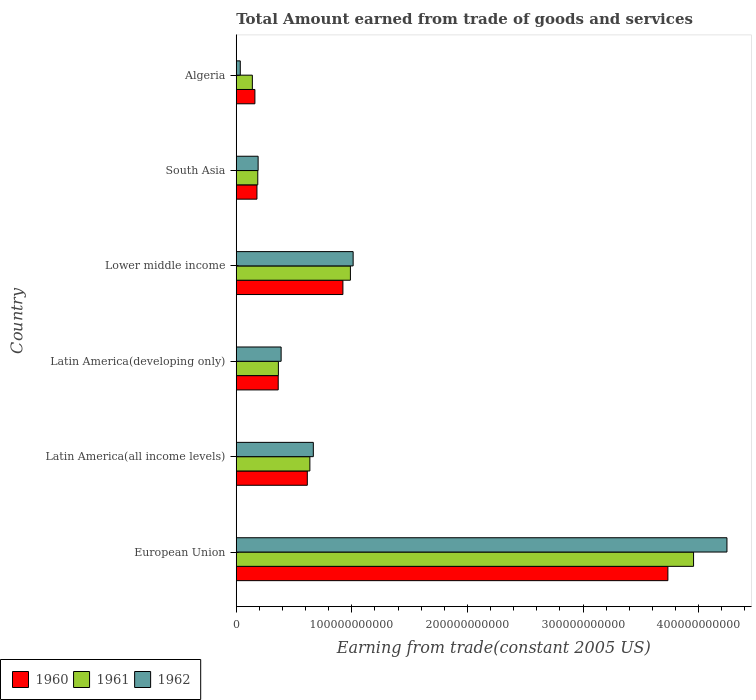How many groups of bars are there?
Keep it short and to the point. 6. Are the number of bars on each tick of the Y-axis equal?
Make the answer very short. Yes. How many bars are there on the 4th tick from the top?
Your answer should be very brief. 3. What is the label of the 5th group of bars from the top?
Provide a succinct answer. Latin America(all income levels). What is the total amount earned by trading goods and services in 1961 in Lower middle income?
Provide a short and direct response. 9.88e+1. Across all countries, what is the maximum total amount earned by trading goods and services in 1961?
Provide a short and direct response. 3.96e+11. Across all countries, what is the minimum total amount earned by trading goods and services in 1961?
Ensure brevity in your answer.  1.39e+1. In which country was the total amount earned by trading goods and services in 1961 maximum?
Give a very brief answer. European Union. In which country was the total amount earned by trading goods and services in 1962 minimum?
Your answer should be very brief. Algeria. What is the total total amount earned by trading goods and services in 1961 in the graph?
Make the answer very short. 6.27e+11. What is the difference between the total amount earned by trading goods and services in 1961 in Algeria and that in South Asia?
Provide a succinct answer. -4.69e+09. What is the difference between the total amount earned by trading goods and services in 1960 in South Asia and the total amount earned by trading goods and services in 1962 in Latin America(developing only)?
Offer a terse response. -2.09e+1. What is the average total amount earned by trading goods and services in 1961 per country?
Your answer should be compact. 1.05e+11. What is the difference between the total amount earned by trading goods and services in 1960 and total amount earned by trading goods and services in 1961 in European Union?
Offer a very short reply. -2.22e+1. What is the ratio of the total amount earned by trading goods and services in 1960 in Algeria to that in Lower middle income?
Provide a succinct answer. 0.17. Is the total amount earned by trading goods and services in 1961 in Lower middle income less than that in South Asia?
Your response must be concise. No. Is the difference between the total amount earned by trading goods and services in 1960 in European Union and Latin America(all income levels) greater than the difference between the total amount earned by trading goods and services in 1961 in European Union and Latin America(all income levels)?
Ensure brevity in your answer.  No. What is the difference between the highest and the second highest total amount earned by trading goods and services in 1962?
Provide a short and direct response. 3.23e+11. What is the difference between the highest and the lowest total amount earned by trading goods and services in 1961?
Your answer should be very brief. 3.82e+11. In how many countries, is the total amount earned by trading goods and services in 1962 greater than the average total amount earned by trading goods and services in 1962 taken over all countries?
Ensure brevity in your answer.  1. Is the sum of the total amount earned by trading goods and services in 1962 in Lower middle income and South Asia greater than the maximum total amount earned by trading goods and services in 1961 across all countries?
Keep it short and to the point. No. What does the 2nd bar from the top in South Asia represents?
Your response must be concise. 1961. What does the 2nd bar from the bottom in South Asia represents?
Ensure brevity in your answer.  1961. How many bars are there?
Offer a terse response. 18. Are all the bars in the graph horizontal?
Keep it short and to the point. Yes. What is the difference between two consecutive major ticks on the X-axis?
Make the answer very short. 1.00e+11. Does the graph contain grids?
Provide a succinct answer. No. Where does the legend appear in the graph?
Offer a terse response. Bottom left. How many legend labels are there?
Keep it short and to the point. 3. How are the legend labels stacked?
Provide a succinct answer. Horizontal. What is the title of the graph?
Provide a short and direct response. Total Amount earned from trade of goods and services. What is the label or title of the X-axis?
Ensure brevity in your answer.  Earning from trade(constant 2005 US). What is the Earning from trade(constant 2005 US) in 1960 in European Union?
Provide a succinct answer. 3.73e+11. What is the Earning from trade(constant 2005 US) of 1961 in European Union?
Offer a very short reply. 3.96e+11. What is the Earning from trade(constant 2005 US) of 1962 in European Union?
Give a very brief answer. 4.24e+11. What is the Earning from trade(constant 2005 US) in 1960 in Latin America(all income levels)?
Offer a terse response. 6.15e+1. What is the Earning from trade(constant 2005 US) of 1961 in Latin America(all income levels)?
Make the answer very short. 6.37e+1. What is the Earning from trade(constant 2005 US) in 1962 in Latin America(all income levels)?
Give a very brief answer. 6.67e+1. What is the Earning from trade(constant 2005 US) of 1960 in Latin America(developing only)?
Your answer should be compact. 3.63e+1. What is the Earning from trade(constant 2005 US) of 1961 in Latin America(developing only)?
Make the answer very short. 3.64e+1. What is the Earning from trade(constant 2005 US) of 1962 in Latin America(developing only)?
Give a very brief answer. 3.88e+1. What is the Earning from trade(constant 2005 US) of 1960 in Lower middle income?
Your answer should be very brief. 9.23e+1. What is the Earning from trade(constant 2005 US) in 1961 in Lower middle income?
Offer a very short reply. 9.88e+1. What is the Earning from trade(constant 2005 US) of 1962 in Lower middle income?
Make the answer very short. 1.01e+11. What is the Earning from trade(constant 2005 US) in 1960 in South Asia?
Your answer should be compact. 1.79e+1. What is the Earning from trade(constant 2005 US) of 1961 in South Asia?
Offer a terse response. 1.86e+1. What is the Earning from trade(constant 2005 US) in 1962 in South Asia?
Keep it short and to the point. 1.89e+1. What is the Earning from trade(constant 2005 US) of 1960 in Algeria?
Your response must be concise. 1.61e+1. What is the Earning from trade(constant 2005 US) in 1961 in Algeria?
Ensure brevity in your answer.  1.39e+1. What is the Earning from trade(constant 2005 US) of 1962 in Algeria?
Offer a terse response. 3.48e+09. Across all countries, what is the maximum Earning from trade(constant 2005 US) in 1960?
Your response must be concise. 3.73e+11. Across all countries, what is the maximum Earning from trade(constant 2005 US) in 1961?
Your answer should be compact. 3.96e+11. Across all countries, what is the maximum Earning from trade(constant 2005 US) in 1962?
Give a very brief answer. 4.24e+11. Across all countries, what is the minimum Earning from trade(constant 2005 US) in 1960?
Offer a terse response. 1.61e+1. Across all countries, what is the minimum Earning from trade(constant 2005 US) in 1961?
Your answer should be very brief. 1.39e+1. Across all countries, what is the minimum Earning from trade(constant 2005 US) in 1962?
Provide a succinct answer. 3.48e+09. What is the total Earning from trade(constant 2005 US) in 1960 in the graph?
Your answer should be very brief. 5.97e+11. What is the total Earning from trade(constant 2005 US) in 1961 in the graph?
Provide a succinct answer. 6.27e+11. What is the total Earning from trade(constant 2005 US) in 1962 in the graph?
Offer a very short reply. 6.54e+11. What is the difference between the Earning from trade(constant 2005 US) of 1960 in European Union and that in Latin America(all income levels)?
Ensure brevity in your answer.  3.12e+11. What is the difference between the Earning from trade(constant 2005 US) of 1961 in European Union and that in Latin America(all income levels)?
Provide a succinct answer. 3.32e+11. What is the difference between the Earning from trade(constant 2005 US) of 1962 in European Union and that in Latin America(all income levels)?
Keep it short and to the point. 3.58e+11. What is the difference between the Earning from trade(constant 2005 US) of 1960 in European Union and that in Latin America(developing only)?
Your answer should be compact. 3.37e+11. What is the difference between the Earning from trade(constant 2005 US) in 1961 in European Union and that in Latin America(developing only)?
Give a very brief answer. 3.59e+11. What is the difference between the Earning from trade(constant 2005 US) in 1962 in European Union and that in Latin America(developing only)?
Provide a succinct answer. 3.86e+11. What is the difference between the Earning from trade(constant 2005 US) of 1960 in European Union and that in Lower middle income?
Your answer should be very brief. 2.81e+11. What is the difference between the Earning from trade(constant 2005 US) in 1961 in European Union and that in Lower middle income?
Your response must be concise. 2.97e+11. What is the difference between the Earning from trade(constant 2005 US) of 1962 in European Union and that in Lower middle income?
Provide a succinct answer. 3.23e+11. What is the difference between the Earning from trade(constant 2005 US) in 1960 in European Union and that in South Asia?
Provide a succinct answer. 3.55e+11. What is the difference between the Earning from trade(constant 2005 US) in 1961 in European Union and that in South Asia?
Your answer should be very brief. 3.77e+11. What is the difference between the Earning from trade(constant 2005 US) of 1962 in European Union and that in South Asia?
Ensure brevity in your answer.  4.06e+11. What is the difference between the Earning from trade(constant 2005 US) of 1960 in European Union and that in Algeria?
Give a very brief answer. 3.57e+11. What is the difference between the Earning from trade(constant 2005 US) in 1961 in European Union and that in Algeria?
Keep it short and to the point. 3.82e+11. What is the difference between the Earning from trade(constant 2005 US) in 1962 in European Union and that in Algeria?
Offer a very short reply. 4.21e+11. What is the difference between the Earning from trade(constant 2005 US) in 1960 in Latin America(all income levels) and that in Latin America(developing only)?
Make the answer very short. 2.52e+1. What is the difference between the Earning from trade(constant 2005 US) of 1961 in Latin America(all income levels) and that in Latin America(developing only)?
Give a very brief answer. 2.72e+1. What is the difference between the Earning from trade(constant 2005 US) of 1962 in Latin America(all income levels) and that in Latin America(developing only)?
Your answer should be compact. 2.79e+1. What is the difference between the Earning from trade(constant 2005 US) of 1960 in Latin America(all income levels) and that in Lower middle income?
Make the answer very short. -3.08e+1. What is the difference between the Earning from trade(constant 2005 US) of 1961 in Latin America(all income levels) and that in Lower middle income?
Your response must be concise. -3.51e+1. What is the difference between the Earning from trade(constant 2005 US) of 1962 in Latin America(all income levels) and that in Lower middle income?
Your answer should be compact. -3.45e+1. What is the difference between the Earning from trade(constant 2005 US) of 1960 in Latin America(all income levels) and that in South Asia?
Make the answer very short. 4.36e+1. What is the difference between the Earning from trade(constant 2005 US) of 1961 in Latin America(all income levels) and that in South Asia?
Provide a short and direct response. 4.51e+1. What is the difference between the Earning from trade(constant 2005 US) of 1962 in Latin America(all income levels) and that in South Asia?
Keep it short and to the point. 4.77e+1. What is the difference between the Earning from trade(constant 2005 US) of 1960 in Latin America(all income levels) and that in Algeria?
Provide a short and direct response. 4.53e+1. What is the difference between the Earning from trade(constant 2005 US) in 1961 in Latin America(all income levels) and that in Algeria?
Your response must be concise. 4.98e+1. What is the difference between the Earning from trade(constant 2005 US) of 1962 in Latin America(all income levels) and that in Algeria?
Your answer should be compact. 6.32e+1. What is the difference between the Earning from trade(constant 2005 US) of 1960 in Latin America(developing only) and that in Lower middle income?
Provide a short and direct response. -5.60e+1. What is the difference between the Earning from trade(constant 2005 US) in 1961 in Latin America(developing only) and that in Lower middle income?
Provide a short and direct response. -6.23e+1. What is the difference between the Earning from trade(constant 2005 US) in 1962 in Latin America(developing only) and that in Lower middle income?
Your answer should be compact. -6.23e+1. What is the difference between the Earning from trade(constant 2005 US) in 1960 in Latin America(developing only) and that in South Asia?
Provide a short and direct response. 1.84e+1. What is the difference between the Earning from trade(constant 2005 US) of 1961 in Latin America(developing only) and that in South Asia?
Your answer should be very brief. 1.78e+1. What is the difference between the Earning from trade(constant 2005 US) of 1962 in Latin America(developing only) and that in South Asia?
Your answer should be compact. 1.99e+1. What is the difference between the Earning from trade(constant 2005 US) of 1960 in Latin America(developing only) and that in Algeria?
Offer a terse response. 2.02e+1. What is the difference between the Earning from trade(constant 2005 US) in 1961 in Latin America(developing only) and that in Algeria?
Give a very brief answer. 2.25e+1. What is the difference between the Earning from trade(constant 2005 US) of 1962 in Latin America(developing only) and that in Algeria?
Give a very brief answer. 3.53e+1. What is the difference between the Earning from trade(constant 2005 US) in 1960 in Lower middle income and that in South Asia?
Your response must be concise. 7.44e+1. What is the difference between the Earning from trade(constant 2005 US) in 1961 in Lower middle income and that in South Asia?
Keep it short and to the point. 8.01e+1. What is the difference between the Earning from trade(constant 2005 US) of 1962 in Lower middle income and that in South Asia?
Your answer should be compact. 8.22e+1. What is the difference between the Earning from trade(constant 2005 US) of 1960 in Lower middle income and that in Algeria?
Provide a succinct answer. 7.61e+1. What is the difference between the Earning from trade(constant 2005 US) in 1961 in Lower middle income and that in Algeria?
Ensure brevity in your answer.  8.48e+1. What is the difference between the Earning from trade(constant 2005 US) of 1962 in Lower middle income and that in Algeria?
Your answer should be compact. 9.76e+1. What is the difference between the Earning from trade(constant 2005 US) of 1960 in South Asia and that in Algeria?
Your response must be concise. 1.77e+09. What is the difference between the Earning from trade(constant 2005 US) in 1961 in South Asia and that in Algeria?
Offer a terse response. 4.69e+09. What is the difference between the Earning from trade(constant 2005 US) in 1962 in South Asia and that in Algeria?
Offer a very short reply. 1.54e+1. What is the difference between the Earning from trade(constant 2005 US) of 1960 in European Union and the Earning from trade(constant 2005 US) of 1961 in Latin America(all income levels)?
Offer a very short reply. 3.10e+11. What is the difference between the Earning from trade(constant 2005 US) in 1960 in European Union and the Earning from trade(constant 2005 US) in 1962 in Latin America(all income levels)?
Make the answer very short. 3.07e+11. What is the difference between the Earning from trade(constant 2005 US) in 1961 in European Union and the Earning from trade(constant 2005 US) in 1962 in Latin America(all income levels)?
Offer a terse response. 3.29e+11. What is the difference between the Earning from trade(constant 2005 US) in 1960 in European Union and the Earning from trade(constant 2005 US) in 1961 in Latin America(developing only)?
Make the answer very short. 3.37e+11. What is the difference between the Earning from trade(constant 2005 US) in 1960 in European Union and the Earning from trade(constant 2005 US) in 1962 in Latin America(developing only)?
Keep it short and to the point. 3.35e+11. What is the difference between the Earning from trade(constant 2005 US) of 1961 in European Union and the Earning from trade(constant 2005 US) of 1962 in Latin America(developing only)?
Your answer should be compact. 3.57e+11. What is the difference between the Earning from trade(constant 2005 US) of 1960 in European Union and the Earning from trade(constant 2005 US) of 1961 in Lower middle income?
Your answer should be compact. 2.75e+11. What is the difference between the Earning from trade(constant 2005 US) of 1960 in European Union and the Earning from trade(constant 2005 US) of 1962 in Lower middle income?
Give a very brief answer. 2.72e+11. What is the difference between the Earning from trade(constant 2005 US) of 1961 in European Union and the Earning from trade(constant 2005 US) of 1962 in Lower middle income?
Provide a succinct answer. 2.94e+11. What is the difference between the Earning from trade(constant 2005 US) of 1960 in European Union and the Earning from trade(constant 2005 US) of 1961 in South Asia?
Keep it short and to the point. 3.55e+11. What is the difference between the Earning from trade(constant 2005 US) in 1960 in European Union and the Earning from trade(constant 2005 US) in 1962 in South Asia?
Provide a succinct answer. 3.54e+11. What is the difference between the Earning from trade(constant 2005 US) of 1961 in European Union and the Earning from trade(constant 2005 US) of 1962 in South Asia?
Offer a terse response. 3.77e+11. What is the difference between the Earning from trade(constant 2005 US) in 1960 in European Union and the Earning from trade(constant 2005 US) in 1961 in Algeria?
Give a very brief answer. 3.59e+11. What is the difference between the Earning from trade(constant 2005 US) of 1960 in European Union and the Earning from trade(constant 2005 US) of 1962 in Algeria?
Your response must be concise. 3.70e+11. What is the difference between the Earning from trade(constant 2005 US) of 1961 in European Union and the Earning from trade(constant 2005 US) of 1962 in Algeria?
Your response must be concise. 3.92e+11. What is the difference between the Earning from trade(constant 2005 US) in 1960 in Latin America(all income levels) and the Earning from trade(constant 2005 US) in 1961 in Latin America(developing only)?
Your answer should be very brief. 2.50e+1. What is the difference between the Earning from trade(constant 2005 US) of 1960 in Latin America(all income levels) and the Earning from trade(constant 2005 US) of 1962 in Latin America(developing only)?
Your answer should be very brief. 2.27e+1. What is the difference between the Earning from trade(constant 2005 US) in 1961 in Latin America(all income levels) and the Earning from trade(constant 2005 US) in 1962 in Latin America(developing only)?
Provide a succinct answer. 2.49e+1. What is the difference between the Earning from trade(constant 2005 US) in 1960 in Latin America(all income levels) and the Earning from trade(constant 2005 US) in 1961 in Lower middle income?
Make the answer very short. -3.73e+1. What is the difference between the Earning from trade(constant 2005 US) in 1960 in Latin America(all income levels) and the Earning from trade(constant 2005 US) in 1962 in Lower middle income?
Provide a short and direct response. -3.96e+1. What is the difference between the Earning from trade(constant 2005 US) of 1961 in Latin America(all income levels) and the Earning from trade(constant 2005 US) of 1962 in Lower middle income?
Offer a very short reply. -3.74e+1. What is the difference between the Earning from trade(constant 2005 US) in 1960 in Latin America(all income levels) and the Earning from trade(constant 2005 US) in 1961 in South Asia?
Your answer should be very brief. 4.29e+1. What is the difference between the Earning from trade(constant 2005 US) of 1960 in Latin America(all income levels) and the Earning from trade(constant 2005 US) of 1962 in South Asia?
Ensure brevity in your answer.  4.26e+1. What is the difference between the Earning from trade(constant 2005 US) of 1961 in Latin America(all income levels) and the Earning from trade(constant 2005 US) of 1962 in South Asia?
Ensure brevity in your answer.  4.48e+1. What is the difference between the Earning from trade(constant 2005 US) of 1960 in Latin America(all income levels) and the Earning from trade(constant 2005 US) of 1961 in Algeria?
Your answer should be very brief. 4.75e+1. What is the difference between the Earning from trade(constant 2005 US) of 1960 in Latin America(all income levels) and the Earning from trade(constant 2005 US) of 1962 in Algeria?
Provide a short and direct response. 5.80e+1. What is the difference between the Earning from trade(constant 2005 US) of 1961 in Latin America(all income levels) and the Earning from trade(constant 2005 US) of 1962 in Algeria?
Make the answer very short. 6.02e+1. What is the difference between the Earning from trade(constant 2005 US) in 1960 in Latin America(developing only) and the Earning from trade(constant 2005 US) in 1961 in Lower middle income?
Offer a terse response. -6.25e+1. What is the difference between the Earning from trade(constant 2005 US) of 1960 in Latin America(developing only) and the Earning from trade(constant 2005 US) of 1962 in Lower middle income?
Ensure brevity in your answer.  -6.48e+1. What is the difference between the Earning from trade(constant 2005 US) of 1961 in Latin America(developing only) and the Earning from trade(constant 2005 US) of 1962 in Lower middle income?
Keep it short and to the point. -6.47e+1. What is the difference between the Earning from trade(constant 2005 US) in 1960 in Latin America(developing only) and the Earning from trade(constant 2005 US) in 1961 in South Asia?
Your answer should be compact. 1.77e+1. What is the difference between the Earning from trade(constant 2005 US) in 1960 in Latin America(developing only) and the Earning from trade(constant 2005 US) in 1962 in South Asia?
Your answer should be compact. 1.74e+1. What is the difference between the Earning from trade(constant 2005 US) in 1961 in Latin America(developing only) and the Earning from trade(constant 2005 US) in 1962 in South Asia?
Offer a terse response. 1.75e+1. What is the difference between the Earning from trade(constant 2005 US) in 1960 in Latin America(developing only) and the Earning from trade(constant 2005 US) in 1961 in Algeria?
Offer a very short reply. 2.24e+1. What is the difference between the Earning from trade(constant 2005 US) in 1960 in Latin America(developing only) and the Earning from trade(constant 2005 US) in 1962 in Algeria?
Make the answer very short. 3.28e+1. What is the difference between the Earning from trade(constant 2005 US) in 1961 in Latin America(developing only) and the Earning from trade(constant 2005 US) in 1962 in Algeria?
Offer a very short reply. 3.30e+1. What is the difference between the Earning from trade(constant 2005 US) in 1960 in Lower middle income and the Earning from trade(constant 2005 US) in 1961 in South Asia?
Offer a very short reply. 7.36e+1. What is the difference between the Earning from trade(constant 2005 US) of 1960 in Lower middle income and the Earning from trade(constant 2005 US) of 1962 in South Asia?
Provide a short and direct response. 7.33e+1. What is the difference between the Earning from trade(constant 2005 US) of 1961 in Lower middle income and the Earning from trade(constant 2005 US) of 1962 in South Asia?
Keep it short and to the point. 7.98e+1. What is the difference between the Earning from trade(constant 2005 US) in 1960 in Lower middle income and the Earning from trade(constant 2005 US) in 1961 in Algeria?
Offer a very short reply. 7.83e+1. What is the difference between the Earning from trade(constant 2005 US) in 1960 in Lower middle income and the Earning from trade(constant 2005 US) in 1962 in Algeria?
Offer a very short reply. 8.88e+1. What is the difference between the Earning from trade(constant 2005 US) of 1961 in Lower middle income and the Earning from trade(constant 2005 US) of 1962 in Algeria?
Keep it short and to the point. 9.53e+1. What is the difference between the Earning from trade(constant 2005 US) of 1960 in South Asia and the Earning from trade(constant 2005 US) of 1961 in Algeria?
Your answer should be very brief. 3.97e+09. What is the difference between the Earning from trade(constant 2005 US) of 1960 in South Asia and the Earning from trade(constant 2005 US) of 1962 in Algeria?
Keep it short and to the point. 1.44e+1. What is the difference between the Earning from trade(constant 2005 US) of 1961 in South Asia and the Earning from trade(constant 2005 US) of 1962 in Algeria?
Ensure brevity in your answer.  1.51e+1. What is the average Earning from trade(constant 2005 US) in 1960 per country?
Offer a terse response. 9.96e+1. What is the average Earning from trade(constant 2005 US) of 1961 per country?
Your answer should be compact. 1.05e+11. What is the average Earning from trade(constant 2005 US) of 1962 per country?
Your answer should be very brief. 1.09e+11. What is the difference between the Earning from trade(constant 2005 US) in 1960 and Earning from trade(constant 2005 US) in 1961 in European Union?
Offer a very short reply. -2.22e+1. What is the difference between the Earning from trade(constant 2005 US) in 1960 and Earning from trade(constant 2005 US) in 1962 in European Union?
Provide a short and direct response. -5.11e+1. What is the difference between the Earning from trade(constant 2005 US) in 1961 and Earning from trade(constant 2005 US) in 1962 in European Union?
Your response must be concise. -2.89e+1. What is the difference between the Earning from trade(constant 2005 US) of 1960 and Earning from trade(constant 2005 US) of 1961 in Latin America(all income levels)?
Offer a terse response. -2.22e+09. What is the difference between the Earning from trade(constant 2005 US) of 1960 and Earning from trade(constant 2005 US) of 1962 in Latin America(all income levels)?
Offer a very short reply. -5.20e+09. What is the difference between the Earning from trade(constant 2005 US) in 1961 and Earning from trade(constant 2005 US) in 1962 in Latin America(all income levels)?
Provide a short and direct response. -2.97e+09. What is the difference between the Earning from trade(constant 2005 US) in 1960 and Earning from trade(constant 2005 US) in 1961 in Latin America(developing only)?
Your answer should be compact. -1.49e+08. What is the difference between the Earning from trade(constant 2005 US) in 1960 and Earning from trade(constant 2005 US) in 1962 in Latin America(developing only)?
Your response must be concise. -2.52e+09. What is the difference between the Earning from trade(constant 2005 US) in 1961 and Earning from trade(constant 2005 US) in 1962 in Latin America(developing only)?
Make the answer very short. -2.37e+09. What is the difference between the Earning from trade(constant 2005 US) of 1960 and Earning from trade(constant 2005 US) of 1961 in Lower middle income?
Provide a short and direct response. -6.49e+09. What is the difference between the Earning from trade(constant 2005 US) in 1960 and Earning from trade(constant 2005 US) in 1962 in Lower middle income?
Your response must be concise. -8.86e+09. What is the difference between the Earning from trade(constant 2005 US) of 1961 and Earning from trade(constant 2005 US) of 1962 in Lower middle income?
Provide a short and direct response. -2.37e+09. What is the difference between the Earning from trade(constant 2005 US) of 1960 and Earning from trade(constant 2005 US) of 1961 in South Asia?
Offer a terse response. -7.18e+08. What is the difference between the Earning from trade(constant 2005 US) in 1960 and Earning from trade(constant 2005 US) in 1962 in South Asia?
Keep it short and to the point. -1.02e+09. What is the difference between the Earning from trade(constant 2005 US) of 1961 and Earning from trade(constant 2005 US) of 1962 in South Asia?
Offer a very short reply. -3.00e+08. What is the difference between the Earning from trade(constant 2005 US) in 1960 and Earning from trade(constant 2005 US) in 1961 in Algeria?
Keep it short and to the point. 2.20e+09. What is the difference between the Earning from trade(constant 2005 US) in 1960 and Earning from trade(constant 2005 US) in 1962 in Algeria?
Offer a terse response. 1.26e+1. What is the difference between the Earning from trade(constant 2005 US) of 1961 and Earning from trade(constant 2005 US) of 1962 in Algeria?
Your answer should be compact. 1.04e+1. What is the ratio of the Earning from trade(constant 2005 US) in 1960 in European Union to that in Latin America(all income levels)?
Offer a very short reply. 6.07. What is the ratio of the Earning from trade(constant 2005 US) of 1961 in European Union to that in Latin America(all income levels)?
Give a very brief answer. 6.21. What is the ratio of the Earning from trade(constant 2005 US) in 1962 in European Union to that in Latin America(all income levels)?
Your response must be concise. 6.37. What is the ratio of the Earning from trade(constant 2005 US) of 1960 in European Union to that in Latin America(developing only)?
Your answer should be compact. 10.29. What is the ratio of the Earning from trade(constant 2005 US) in 1961 in European Union to that in Latin America(developing only)?
Offer a very short reply. 10.85. What is the ratio of the Earning from trade(constant 2005 US) of 1962 in European Union to that in Latin America(developing only)?
Give a very brief answer. 10.94. What is the ratio of the Earning from trade(constant 2005 US) of 1960 in European Union to that in Lower middle income?
Offer a very short reply. 4.05. What is the ratio of the Earning from trade(constant 2005 US) in 1961 in European Union to that in Lower middle income?
Your answer should be compact. 4.01. What is the ratio of the Earning from trade(constant 2005 US) in 1962 in European Union to that in Lower middle income?
Make the answer very short. 4.2. What is the ratio of the Earning from trade(constant 2005 US) of 1960 in European Union to that in South Asia?
Keep it short and to the point. 20.86. What is the ratio of the Earning from trade(constant 2005 US) of 1961 in European Union to that in South Asia?
Ensure brevity in your answer.  21.25. What is the ratio of the Earning from trade(constant 2005 US) in 1962 in European Union to that in South Asia?
Provide a short and direct response. 22.44. What is the ratio of the Earning from trade(constant 2005 US) in 1960 in European Union to that in Algeria?
Offer a terse response. 23.15. What is the ratio of the Earning from trade(constant 2005 US) in 1961 in European Union to that in Algeria?
Offer a very short reply. 28.4. What is the ratio of the Earning from trade(constant 2005 US) of 1962 in European Union to that in Algeria?
Your answer should be very brief. 121.88. What is the ratio of the Earning from trade(constant 2005 US) in 1960 in Latin America(all income levels) to that in Latin America(developing only)?
Your response must be concise. 1.69. What is the ratio of the Earning from trade(constant 2005 US) in 1961 in Latin America(all income levels) to that in Latin America(developing only)?
Provide a short and direct response. 1.75. What is the ratio of the Earning from trade(constant 2005 US) in 1962 in Latin America(all income levels) to that in Latin America(developing only)?
Offer a terse response. 1.72. What is the ratio of the Earning from trade(constant 2005 US) in 1960 in Latin America(all income levels) to that in Lower middle income?
Provide a short and direct response. 0.67. What is the ratio of the Earning from trade(constant 2005 US) in 1961 in Latin America(all income levels) to that in Lower middle income?
Provide a short and direct response. 0.65. What is the ratio of the Earning from trade(constant 2005 US) in 1962 in Latin America(all income levels) to that in Lower middle income?
Your answer should be very brief. 0.66. What is the ratio of the Earning from trade(constant 2005 US) in 1960 in Latin America(all income levels) to that in South Asia?
Keep it short and to the point. 3.43. What is the ratio of the Earning from trade(constant 2005 US) of 1961 in Latin America(all income levels) to that in South Asia?
Provide a short and direct response. 3.42. What is the ratio of the Earning from trade(constant 2005 US) of 1962 in Latin America(all income levels) to that in South Asia?
Ensure brevity in your answer.  3.52. What is the ratio of the Earning from trade(constant 2005 US) of 1960 in Latin America(all income levels) to that in Algeria?
Make the answer very short. 3.81. What is the ratio of the Earning from trade(constant 2005 US) of 1961 in Latin America(all income levels) to that in Algeria?
Offer a very short reply. 4.57. What is the ratio of the Earning from trade(constant 2005 US) of 1962 in Latin America(all income levels) to that in Algeria?
Offer a very short reply. 19.14. What is the ratio of the Earning from trade(constant 2005 US) in 1960 in Latin America(developing only) to that in Lower middle income?
Provide a short and direct response. 0.39. What is the ratio of the Earning from trade(constant 2005 US) in 1961 in Latin America(developing only) to that in Lower middle income?
Offer a terse response. 0.37. What is the ratio of the Earning from trade(constant 2005 US) of 1962 in Latin America(developing only) to that in Lower middle income?
Give a very brief answer. 0.38. What is the ratio of the Earning from trade(constant 2005 US) of 1960 in Latin America(developing only) to that in South Asia?
Keep it short and to the point. 2.03. What is the ratio of the Earning from trade(constant 2005 US) in 1961 in Latin America(developing only) to that in South Asia?
Make the answer very short. 1.96. What is the ratio of the Earning from trade(constant 2005 US) in 1962 in Latin America(developing only) to that in South Asia?
Offer a terse response. 2.05. What is the ratio of the Earning from trade(constant 2005 US) in 1960 in Latin America(developing only) to that in Algeria?
Your response must be concise. 2.25. What is the ratio of the Earning from trade(constant 2005 US) in 1961 in Latin America(developing only) to that in Algeria?
Your answer should be compact. 2.62. What is the ratio of the Earning from trade(constant 2005 US) of 1962 in Latin America(developing only) to that in Algeria?
Make the answer very short. 11.14. What is the ratio of the Earning from trade(constant 2005 US) of 1960 in Lower middle income to that in South Asia?
Provide a succinct answer. 5.15. What is the ratio of the Earning from trade(constant 2005 US) of 1961 in Lower middle income to that in South Asia?
Your answer should be compact. 5.3. What is the ratio of the Earning from trade(constant 2005 US) of 1962 in Lower middle income to that in South Asia?
Make the answer very short. 5.34. What is the ratio of the Earning from trade(constant 2005 US) in 1960 in Lower middle income to that in Algeria?
Your response must be concise. 5.72. What is the ratio of the Earning from trade(constant 2005 US) of 1961 in Lower middle income to that in Algeria?
Keep it short and to the point. 7.09. What is the ratio of the Earning from trade(constant 2005 US) of 1962 in Lower middle income to that in Algeria?
Your answer should be compact. 29.03. What is the ratio of the Earning from trade(constant 2005 US) in 1960 in South Asia to that in Algeria?
Offer a very short reply. 1.11. What is the ratio of the Earning from trade(constant 2005 US) of 1961 in South Asia to that in Algeria?
Make the answer very short. 1.34. What is the ratio of the Earning from trade(constant 2005 US) in 1962 in South Asia to that in Algeria?
Give a very brief answer. 5.43. What is the difference between the highest and the second highest Earning from trade(constant 2005 US) of 1960?
Give a very brief answer. 2.81e+11. What is the difference between the highest and the second highest Earning from trade(constant 2005 US) of 1961?
Provide a succinct answer. 2.97e+11. What is the difference between the highest and the second highest Earning from trade(constant 2005 US) of 1962?
Give a very brief answer. 3.23e+11. What is the difference between the highest and the lowest Earning from trade(constant 2005 US) in 1960?
Keep it short and to the point. 3.57e+11. What is the difference between the highest and the lowest Earning from trade(constant 2005 US) of 1961?
Your response must be concise. 3.82e+11. What is the difference between the highest and the lowest Earning from trade(constant 2005 US) of 1962?
Provide a succinct answer. 4.21e+11. 